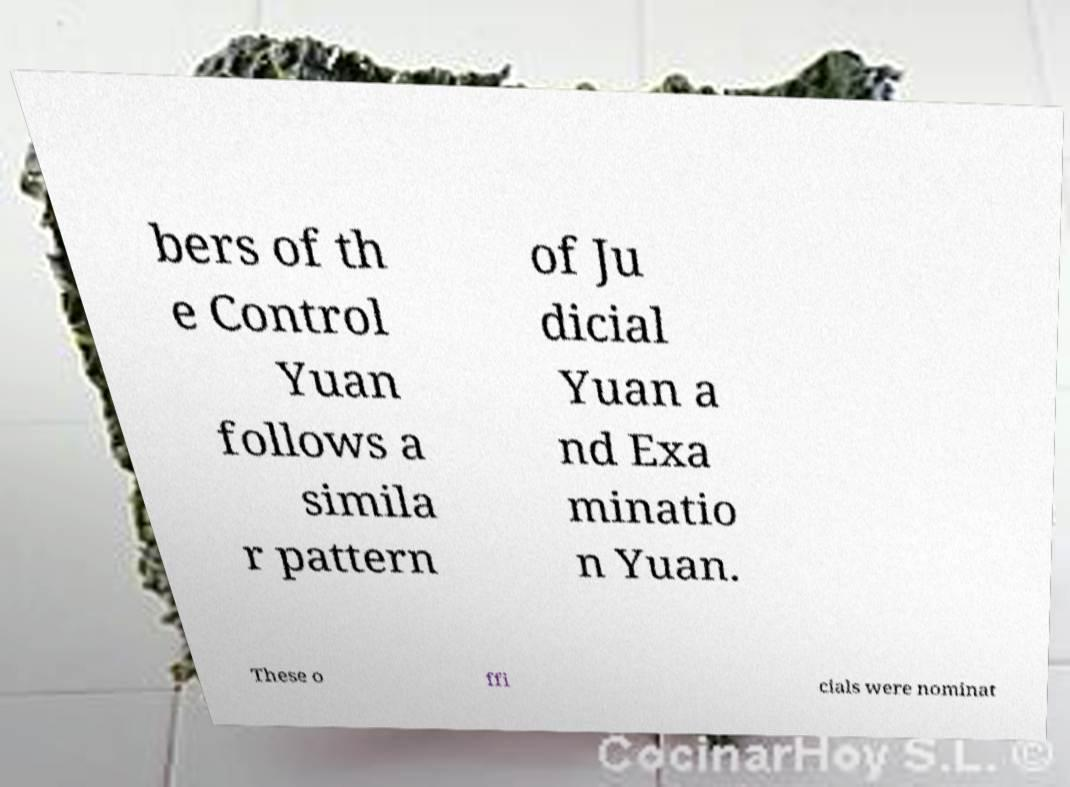Please read and relay the text visible in this image. What does it say? bers of th e Control Yuan follows a simila r pattern of Ju dicial Yuan a nd Exa minatio n Yuan. These o ffi cials were nominat 